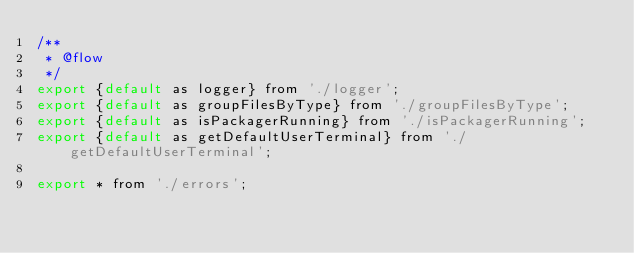Convert code to text. <code><loc_0><loc_0><loc_500><loc_500><_JavaScript_>/**
 * @flow
 */
export {default as logger} from './logger';
export {default as groupFilesByType} from './groupFilesByType';
export {default as isPackagerRunning} from './isPackagerRunning';
export {default as getDefaultUserTerminal} from './getDefaultUserTerminal';

export * from './errors';
</code> 